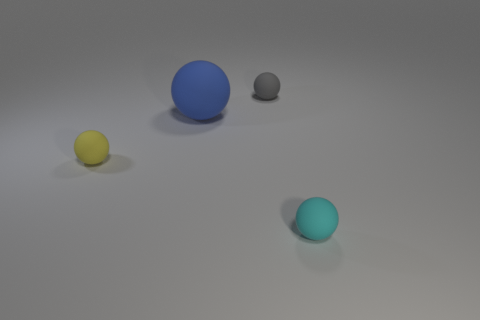What size is the blue ball that is made of the same material as the gray sphere?
Provide a succinct answer. Large. Are there an equal number of things behind the gray matte thing and tiny yellow rubber balls?
Ensure brevity in your answer.  No. Is there anything else that has the same size as the blue ball?
Keep it short and to the point. No. What is the material of the small thing that is in front of the object that is to the left of the blue sphere?
Your answer should be very brief. Rubber. What shape is the object that is both on the right side of the small yellow rubber object and in front of the large blue matte object?
Keep it short and to the point. Sphere. There is a blue object that is the same shape as the tiny cyan matte object; what size is it?
Keep it short and to the point. Large. Is the number of big things behind the large rubber thing less than the number of small gray objects?
Your response must be concise. Yes. How big is the ball in front of the small yellow sphere?
Your answer should be very brief. Small. There is another big matte object that is the same shape as the yellow rubber object; what color is it?
Your answer should be compact. Blue. There is a small sphere to the left of the small thing that is behind the tiny yellow rubber ball; are there any small cyan rubber spheres that are in front of it?
Your answer should be compact. Yes. 